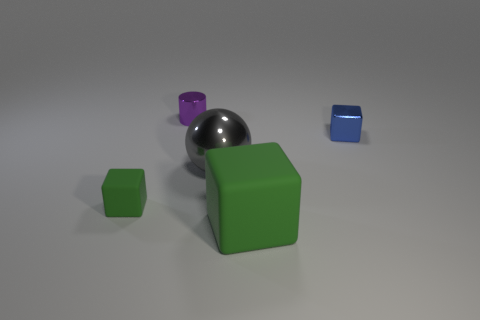Is there a light source within this image, and if so, can you describe its likely location and characteristics? There is indeed a light source in the image, as evidenced by the shadows cast by the objects. Judging by the direction of these shadows, the light appears to be coming from the upper left side of the frame. The light source produces soft shadows, which suggests it might be diffused, either from an indirect light source or through the use of a diffuser in a studio setup. 